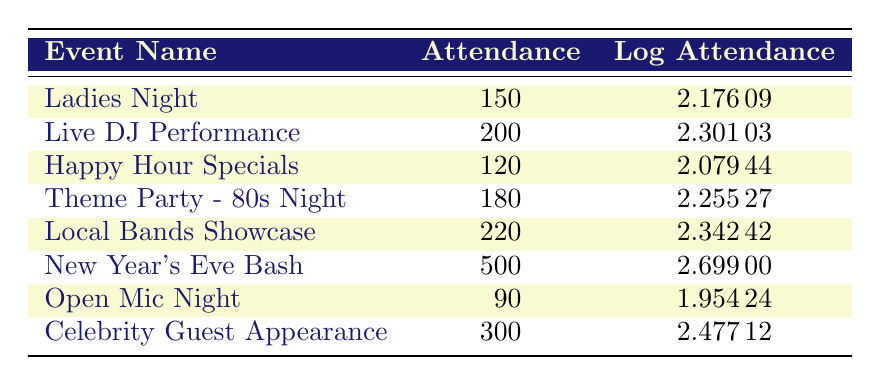What is the attendance for the "New Year's Eve Bash"? The table lists the "New Year's Eve Bash" under the event name column, and its corresponding attendance value is directly noted next to it as 500.
Answer: 500 Which event had the highest logarithmic attendance? By comparing the values in the "Log Attendance" column, the highest value is 2.69900, which corresponds to the "New Year's Eve Bash".
Answer: New Year's Eve Bash What is the average attendance of all listed events? To calculate the average, sum up all attendance values: (150 + 200 + 120 + 180 + 220 + 500 + 90 + 300) = 1860. There are 8 events, thus the average is 1860 / 8 = 232.5.
Answer: 232.5 Is the attendance of the "Open Mic Night" more than 100? The attendance for "Open Mic Night" is 90, as stated in the table. Since 90 is less than 100, the statement is false.
Answer: No What is the total attendance for events with a logarithmic attendance greater than 2.3? First, identify which events have a logarithmic attendance greater than 2.3: "Local Bands Showcase" (220), "New Year's Eve Bash" (500), and "Celebrity Guest Appearance" (300). Adding these gives: 220 + 500 + 300 = 1020.
Answer: 1020 How many events had an attendance lower than 150? Referring to the attendance column, the events with attendance lower than 150 are "Happy Hour Specials" (120) and "Open Mic Night" (90), totaling 2 events.
Answer: 2 What is the difference in attendance between the "Live DJ Performance" and "Happy Hour Specials"? Attendance for "Live DJ Performance" is 200 and for "Happy Hour Specials" is 120. The difference is calculated as 200 - 120 = 80.
Answer: 80 Which event has the closest attendance to 200? Looking at the attendance figures, "Live DJ Performance" has 200, while "Theme Party - 80s Night" has 180 and "Local Bands Showcase" has 220. The closest is "Live DJ Performance" which matches exactly.
Answer: Live DJ Performance 